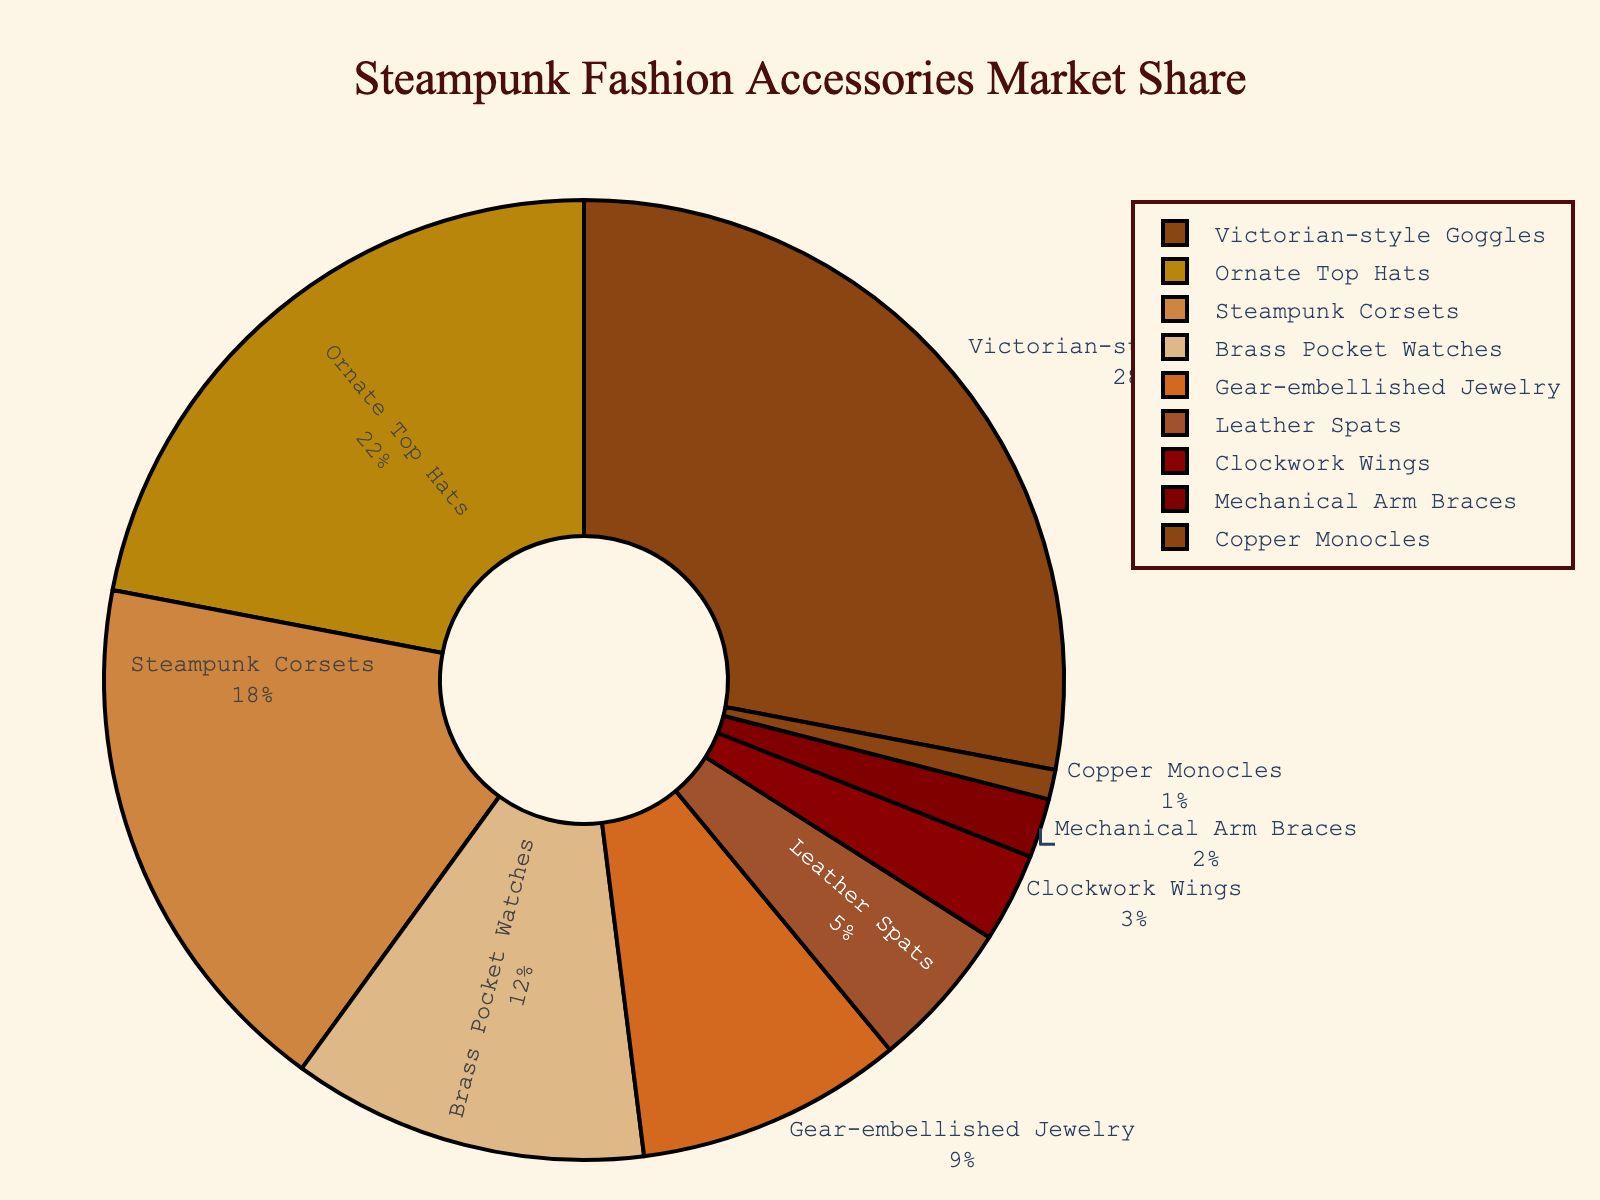Which product holds the largest market share? By analyzing the market share percentages, the Victorian-style Goggles have the highest value at 28%.
Answer: Victorian-style Goggles What is the total market share of the top three products combined? Adding the market shares of Victorian-style Goggles (28%), Ornate Top Hats (22%), and Steampunk Corsets (18%) results in 28 + 22 + 18 = 68%.
Answer: 68% Which product has a larger market share: Brass Pocket Watches or Gear-embellished Jewelry? Comparing the market shares, Brass Pocket Watches have 12% and Gear-embellished Jewelry has 9%. 12% is greater than 9%.
Answer: Brass Pocket Watches What is the difference in market share between Leather Spats and Clockwork Wings? Subtract the market share of Clockwork Wings (3%) from the market share of Leather Spats (5%). 5% - 3% = 2%.
Answer: 2% What percentage of the market is not accounted for by Victorian-style Goggles and Ornate Top Hats combined? Adding the market share of Victorian-style Goggles (28%) and Ornate Top Hats (22%) gives 28% + 22% = 50%. The remaining market share is 100% - 50% = 50%.
Answer: 50% How many products have a market share of less than 10%? Products with less than 10% market share include: Gear-embellished Jewelry (9%), Leather Spats (5%), Clockwork Wings (3%), Mechanical Arm Braces (2%), and Copper Monocles (1%). There are 5 such products.
Answer: 5 What is the combined market share of the least represented three products? Adding the market shares of Mechanical Arm Braces (2%), Copper Monocles (1%), and Clockwork Wings (3%) results in 2% + 1% + 3% = 6%.
Answer: 6% Which products have a market share greater than 10%? Products with market shares greater than 10% are Victorian-style Goggles (28%), Ornate Top Hats (22%), Steampunk Corsets (18%), and Brass Pocket Watches (12%).
Answer: Victorian-style Goggles, Ornate Top Hats, Steampunk Corsets, Brass Pocket Watches Which product occupies the smallest segment in the pie chart? Copper Monocles hold the smallest market share at 1%, making them the smallest segment in the pie chart.
Answer: Copper Monocles 